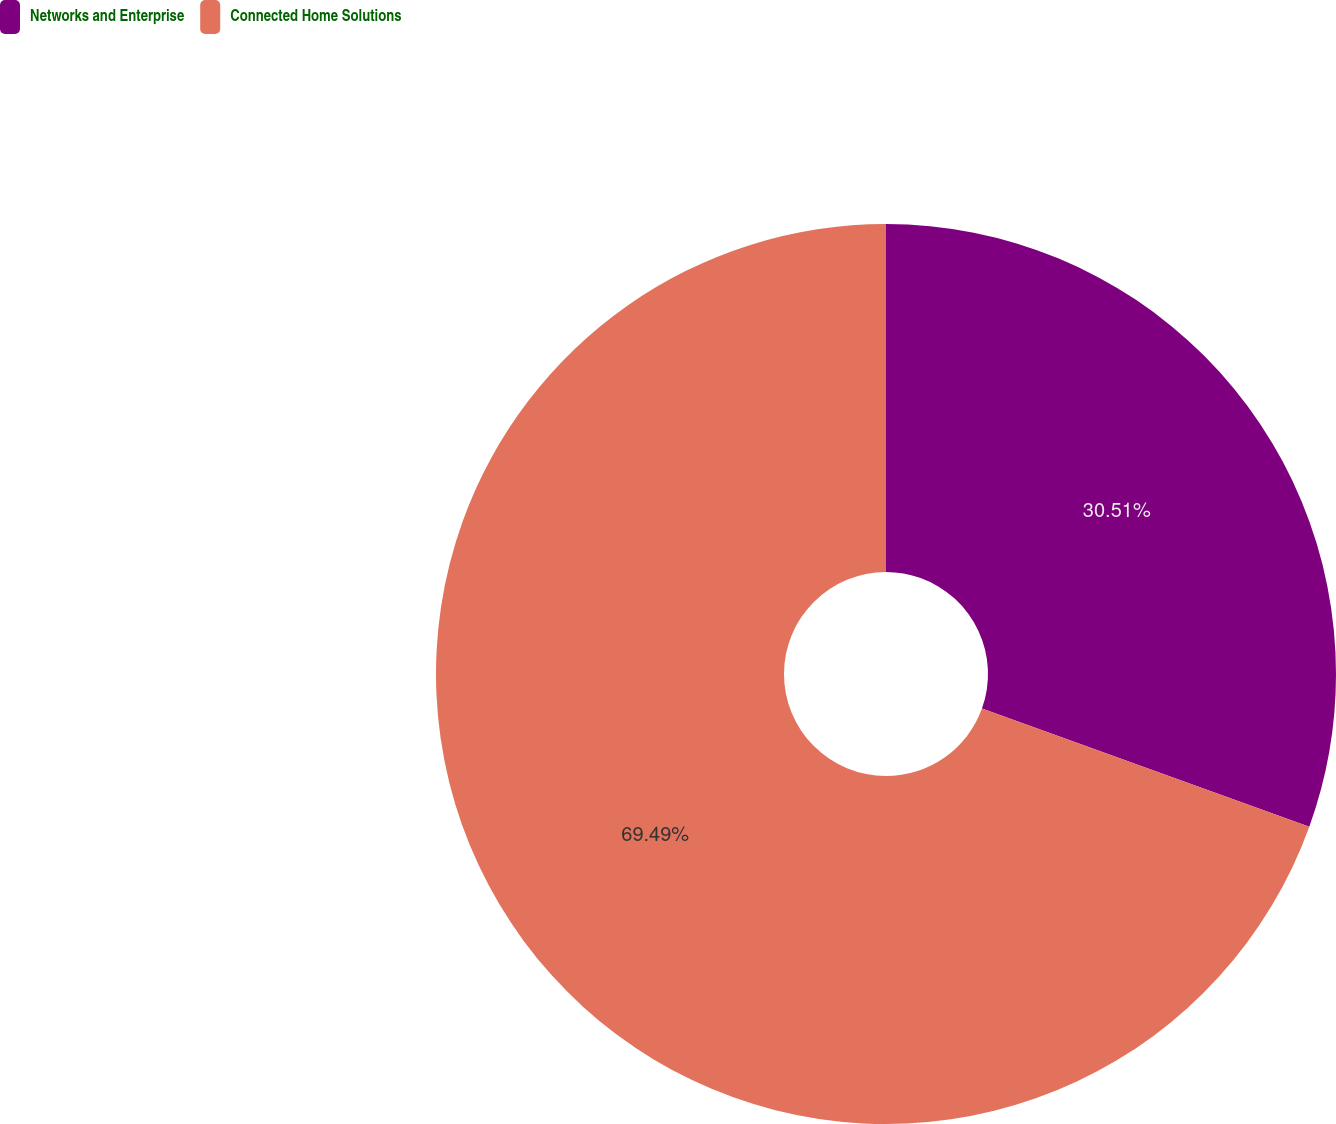Convert chart. <chart><loc_0><loc_0><loc_500><loc_500><pie_chart><fcel>Networks and Enterprise<fcel>Connected Home Solutions<nl><fcel>30.51%<fcel>69.49%<nl></chart> 